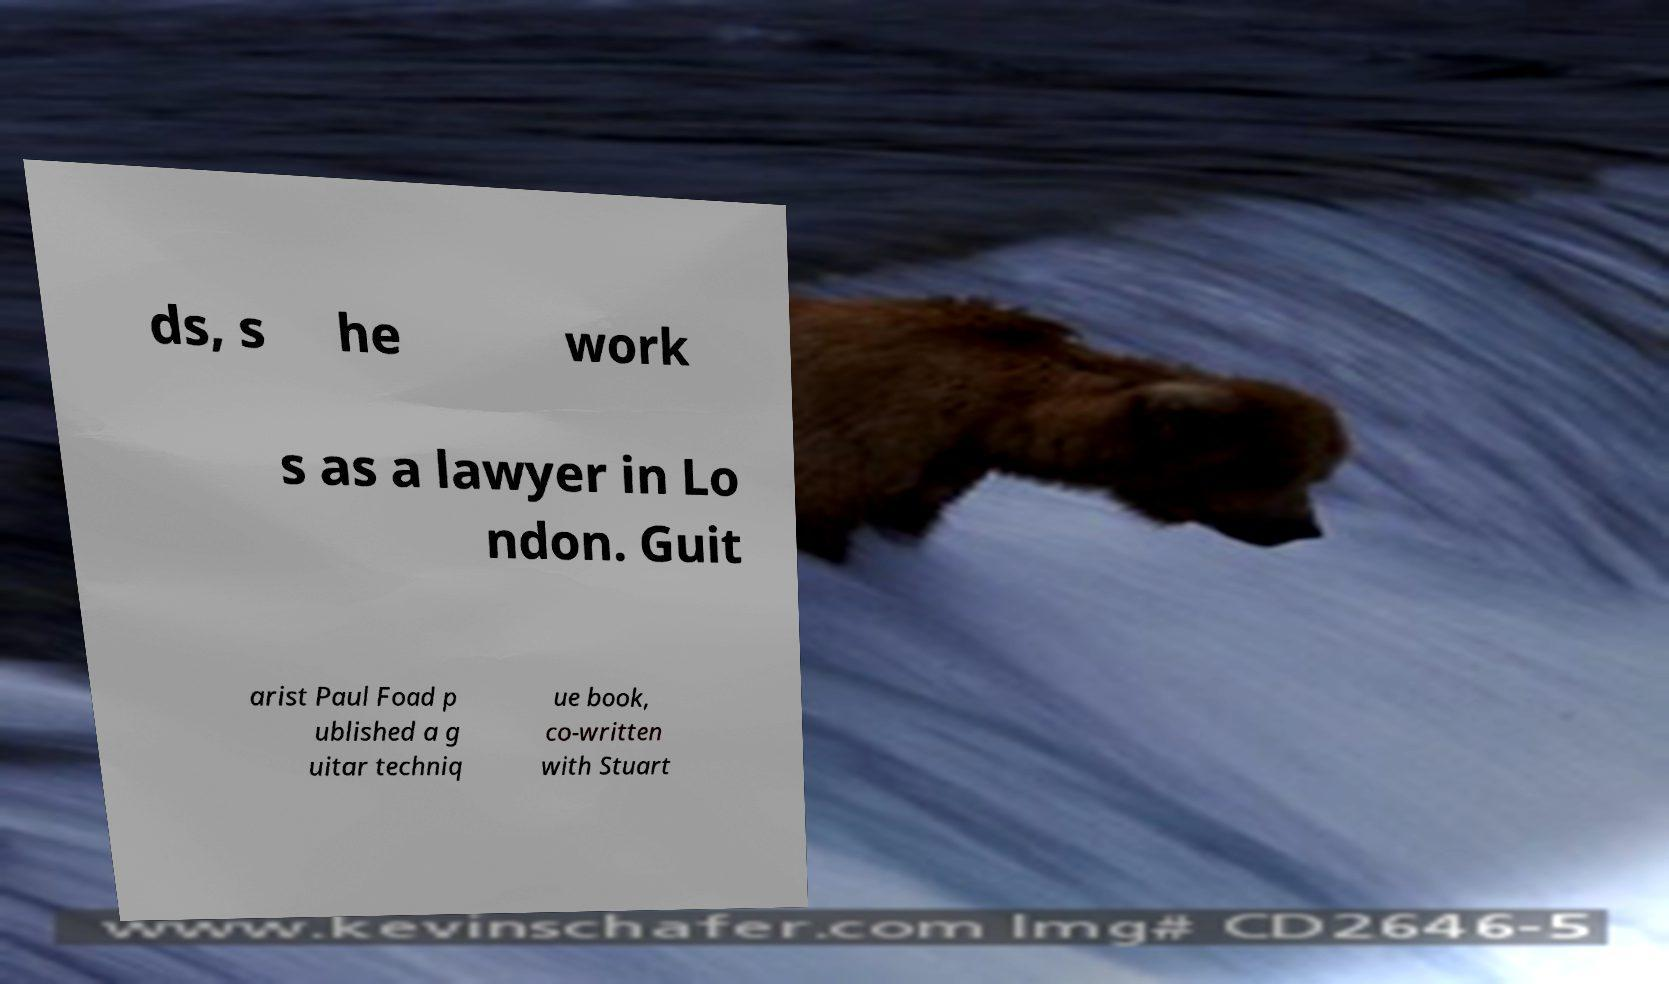There's text embedded in this image that I need extracted. Can you transcribe it verbatim? ds, s he work s as a lawyer in Lo ndon. Guit arist Paul Foad p ublished a g uitar techniq ue book, co-written with Stuart 